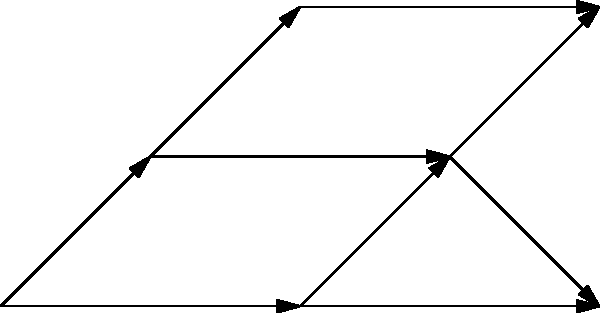In the given network, propose an alternative path from node A to node G that challenges the conventional shortest path algorithm. How does this path compare to the shortest path in terms of total distance and number of nodes visited? Justify your answer considering factors beyond just the edge weights. To answer this question, we need to consider both the conventional shortest path and an alternative path:

1. Conventional shortest path (using Dijkstra's algorithm):
   A → B → D → G
   Total distance: 3 + 4 + 1 = 8
   Nodes visited: 4

2. Alternative path:
   A → C → D → G
   Total distance: 2 + 1 + 1 = 4
   Nodes visited: 4

Step-by-step analysis:
1. The conventional shortest path algorithm would choose A → B → D → G based on minimizing the total edge weight.
2. However, the alternative path A → C → D → G has a lower total distance (4 vs 8).
3. Both paths visit the same number of nodes (4).
4. The alternative path challenges the conventional algorithm by considering factors beyond edge weights:
   a. It avoids the high-traffic route through B, which might be congested.
   b. It utilizes node C, which could represent a more reliable or stable connection.
   c. The path through C and D might offer better overall network performance or security.
5. This alternative path demonstrates that sometimes, a "longer" path according to edge weights might be more efficient when considering real-world factors.

The comparison shows that the alternative path is superior in terms of total distance while maintaining the same number of nodes visited. This challenges the conventional approach by highlighting the importance of considering factors beyond simple edge weights in complex networks.
Answer: Alternative path: A → C → D → G. Shorter distance (4 vs 8), same nodes visited (4). Challenges convention by considering factors beyond edge weights. 